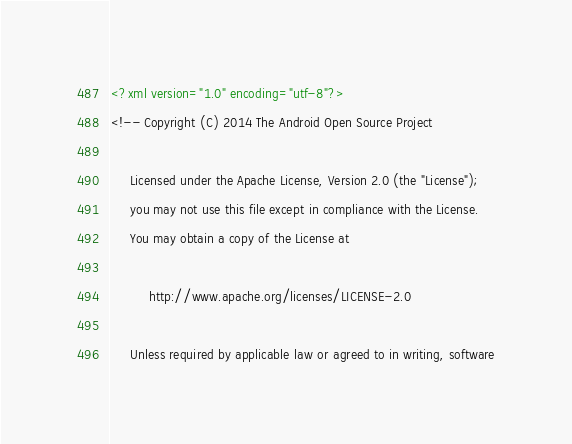<code> <loc_0><loc_0><loc_500><loc_500><_XML_><?xml version="1.0" encoding="utf-8"?>
<!-- Copyright (C) 2014 The Android Open Source Project

     Licensed under the Apache License, Version 2.0 (the "License");
     you may not use this file except in compliance with the License.
     You may obtain a copy of the License at

          http://www.apache.org/licenses/LICENSE-2.0

     Unless required by applicable law or agreed to in writing, software</code> 